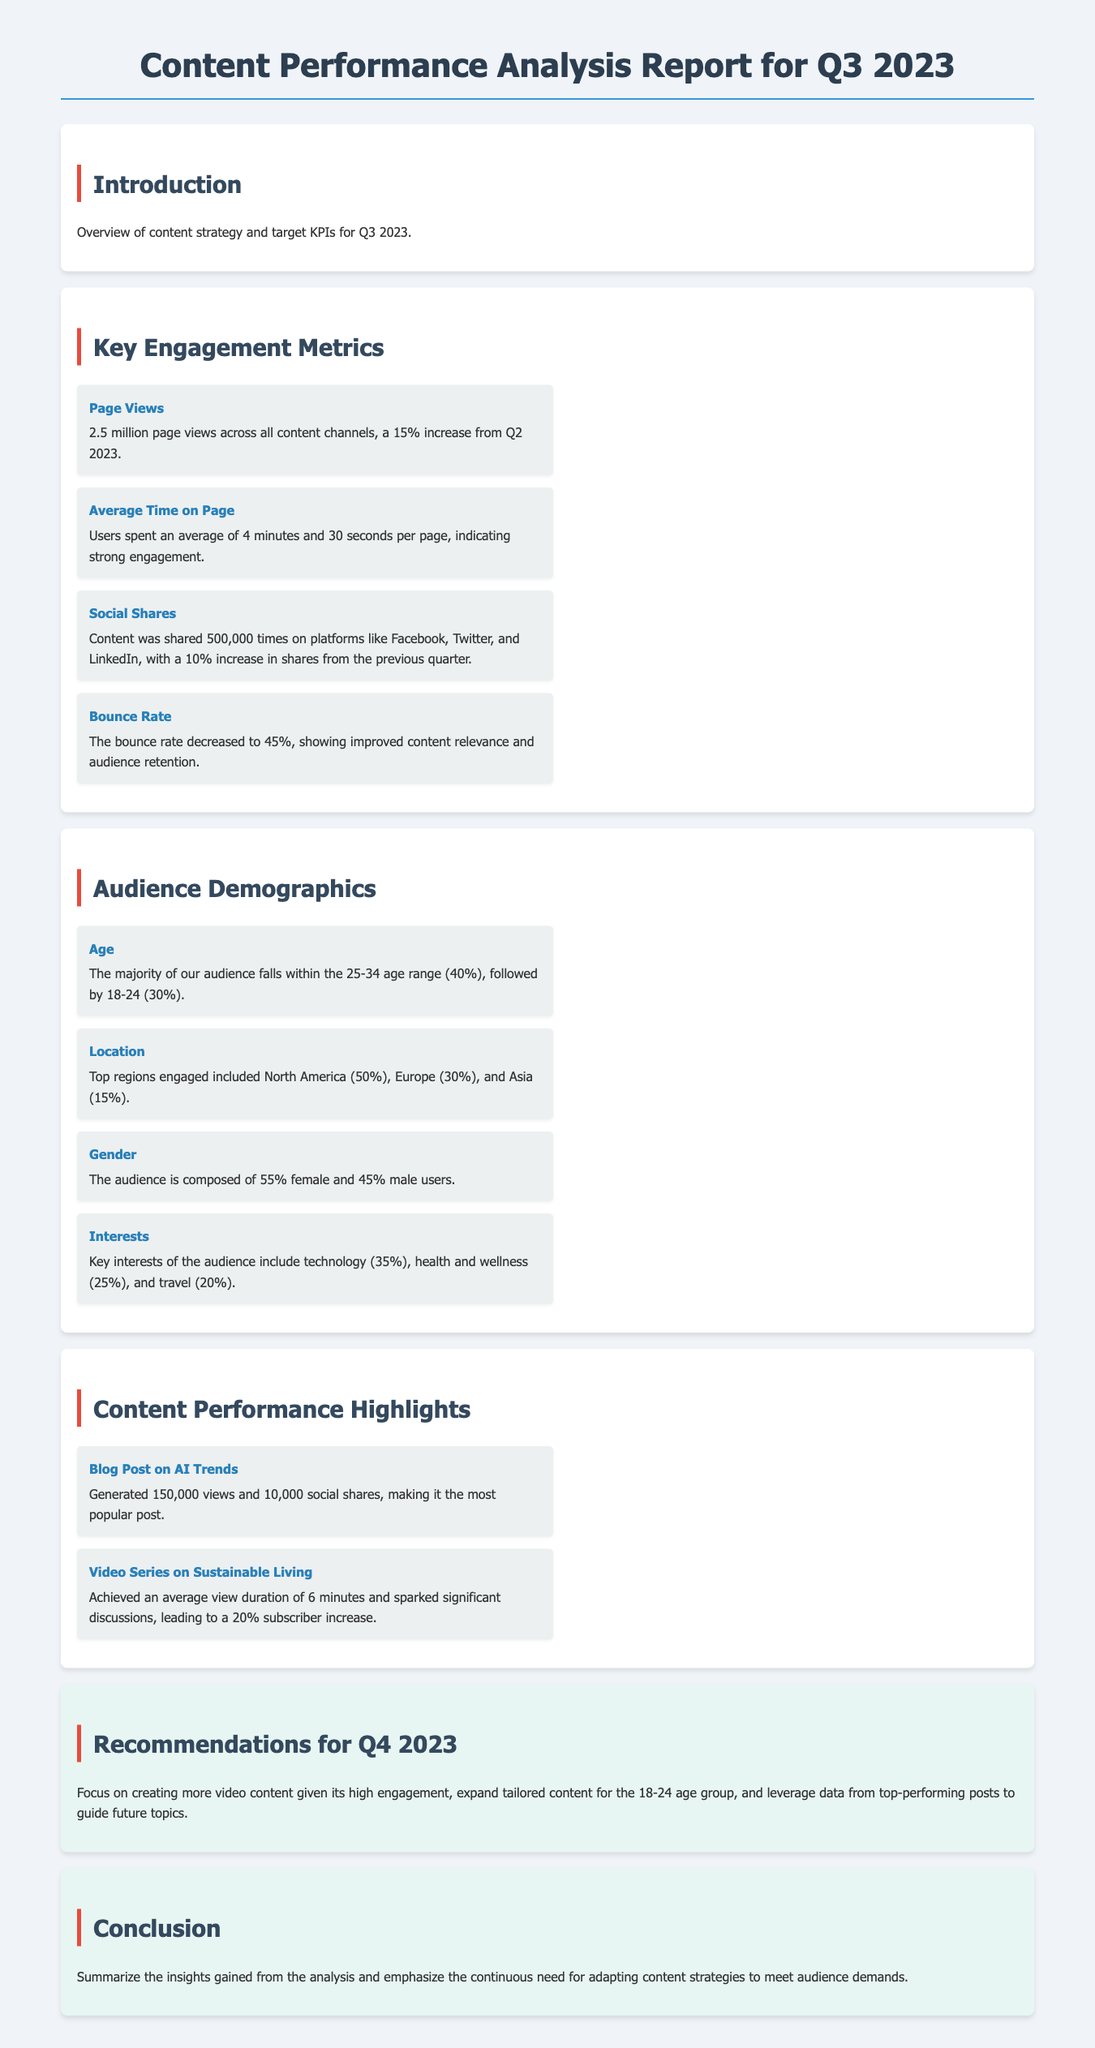What was the total number of page views? The total number of page views is explicitly stated as 2.5 million across all content channels.
Answer: 2.5 million What was the average time spent on page? The average time spent on page is provided in the metrics section, which is 4 minutes and 30 seconds.
Answer: 4 minutes and 30 seconds What percentage of the audience falls within the 25-34 age range? The document states that 40% of the audience is within the 25-34 age range, according to the demographics section.
Answer: 40% Which content piece generated the most views? The document highlights that the blog post on AI Trends generated 150,000 views, making it the most popular post.
Answer: Blog Post on AI Trends What was the bounce rate reported in Q3 2023? The bounce rate as mentioned in the metrics section is 45%, indicating improved content relevance and audience retention.
Answer: 45% Which audience interests are mentioned? Key interests of the audience include technology, health and wellness, and travel, as stated in the demographics section.
Answer: Technology, health and wellness, travel What recommendation is made for Q4 2023 regarding content creation? The recommendation suggests focusing on creating more video content due to its high engagement levels noted in the analysis.
Answer: Creating more video content What was the increase in social shares from the previous quarter? The document notes a 10% increase in social shares from the previous quarter, indicating growth in content sharing.
Answer: 10% What is the conclusion emphasized in the report? The conclusion underlines the continuous need for adapting content strategies to meet audience demands, as summarized in the conclusion section.
Answer: Adapting content strategies 